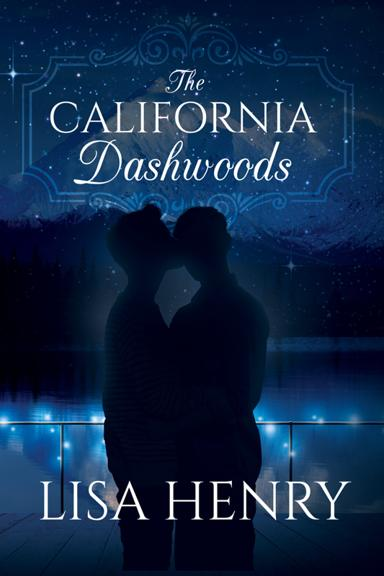Can you describe the mood or atmosphere conveyed by the book cover? The book cover projects a romantic and serene atmosphere, using a deep blue night sky and subtle lighting to create a sense of intimacy and mystery, perfect for a love story. 